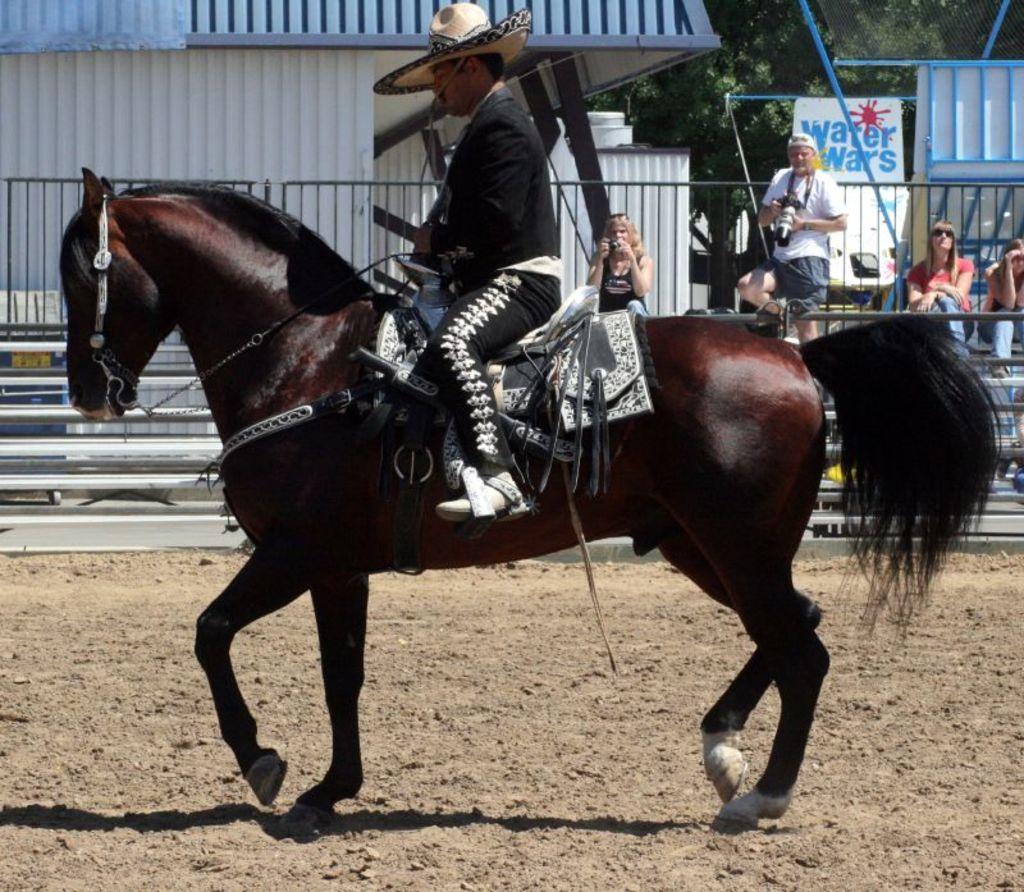Please provide a concise description of this image. In this image we can see one person is riding a horse in ground back side we can see some people are sitting and some people are standing and they are taking pictures. 